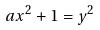<formula> <loc_0><loc_0><loc_500><loc_500>a x ^ { 2 } + 1 = y ^ { 2 }</formula> 